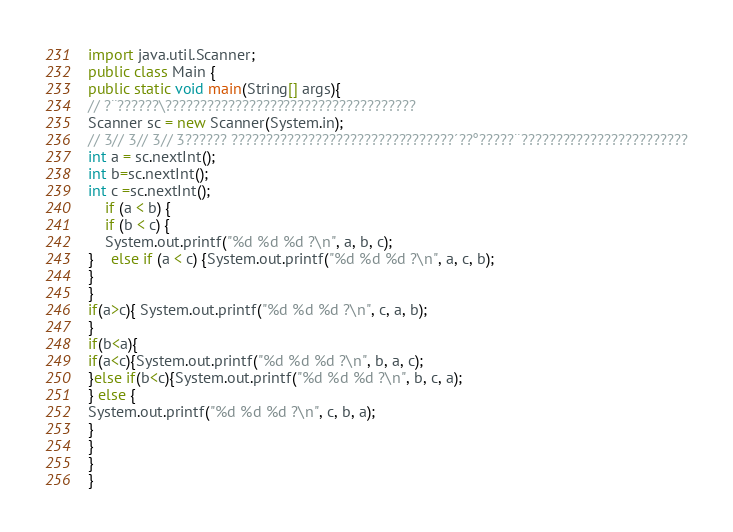Convert code to text. <code><loc_0><loc_0><loc_500><loc_500><_Java_>import java.util.Scanner;
public class Main {
public static void main(String[] args){
// ?¨??????\????????????????????????????????????
Scanner sc = new Scanner(System.in);
// 3// 3// 3// 3?????? ????????????????????????????????´??°?????¨????????????????????????
int a = sc.nextInt(); 
int b=sc.nextInt();
int c =sc.nextInt();
	if (a < b) { 
	if (b < c) { 
	System.out.printf("%d %d %d ?\n", a, b, c);
} 	else if (a < c) {System.out.printf("%d %d %d ?\n", a, c, b);  
}
} 
if(a>c){ System.out.printf("%d %d %d ?\n", c, a, b);
}
if(b<a){
if(a<c){System.out.printf("%d %d %d ?\n", b, a, c);
}else if(b<c){System.out.printf("%d %d %d ?\n", b, c, a);
} else {
System.out.printf("%d %d %d ?\n", c, b, a);
}
}
}
}</code> 